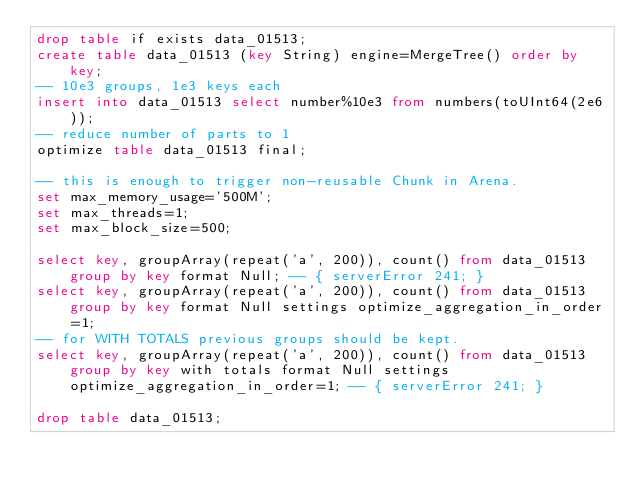<code> <loc_0><loc_0><loc_500><loc_500><_SQL_>drop table if exists data_01513;
create table data_01513 (key String) engine=MergeTree() order by key;
-- 10e3 groups, 1e3 keys each
insert into data_01513 select number%10e3 from numbers(toUInt64(2e6));
-- reduce number of parts to 1
optimize table data_01513 final;

-- this is enough to trigger non-reusable Chunk in Arena.
set max_memory_usage='500M';
set max_threads=1;
set max_block_size=500;

select key, groupArray(repeat('a', 200)), count() from data_01513 group by key format Null; -- { serverError 241; }
select key, groupArray(repeat('a', 200)), count() from data_01513 group by key format Null settings optimize_aggregation_in_order=1;
-- for WITH TOTALS previous groups should be kept.
select key, groupArray(repeat('a', 200)), count() from data_01513 group by key with totals format Null settings optimize_aggregation_in_order=1; -- { serverError 241; }

drop table data_01513;
</code> 